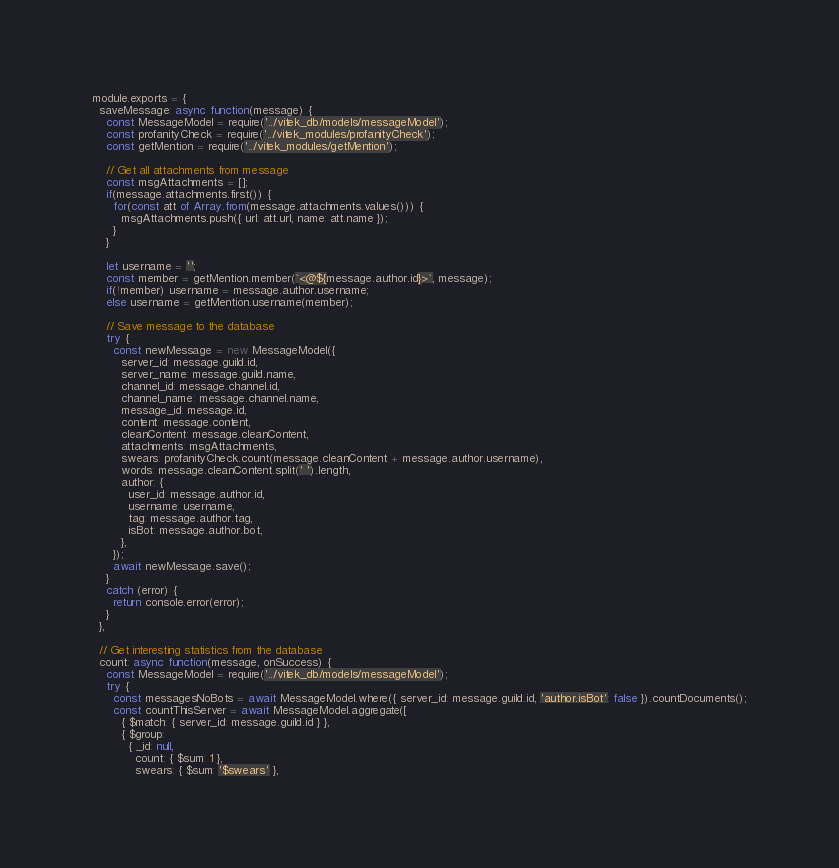<code> <loc_0><loc_0><loc_500><loc_500><_JavaScript_>module.exports = {
  saveMessage: async function(message) {
    const MessageModel = require('../vitek_db/models/messageModel');
    const profanityCheck = require('../vitek_modules/profanityCheck');
    const getMention = require('../vitek_modules/getMention');

    // Get all attachments from message
    const msgAttachments = [];
    if(message.attachments.first()) {
      for(const att of Array.from(message.attachments.values())) {
        msgAttachments.push({ url: att.url, name: att.name });
      }
    }

    let username = '';
    const member = getMention.member(`<@${message.author.id}>`, message);
    if(!member) username = message.author.username;
    else username = getMention.username(member);

    // Save message to the database
    try {
      const newMessage = new MessageModel({
        server_id: message.guild.id,
        server_name: message.guild.name,
        channel_id: message.channel.id,
        channel_name: message.channel.name,
        message_id: message.id,
        content: message.content,
        cleanContent: message.cleanContent,
        attachments: msgAttachments,
        swears: profanityCheck.count(message.cleanContent + message.author.username),
        words: message.cleanContent.split(' ').length,
        author: {
          user_id: message.author.id,
          username: username,
          tag: message.author.tag,
          isBot: message.author.bot,
        },
      });
      await newMessage.save();
    }
    catch (error) {
      return console.error(error);
    }
  },

  // Get interesting statistics from the database
  count: async function(message, onSuccess) {
    const MessageModel = require('../vitek_db/models/messageModel');
    try {
      const messagesNoBots = await MessageModel.where({ server_id: message.guild.id, 'author.isBot': false }).countDocuments();
      const countThisServer = await MessageModel.aggregate([
        { $match: { server_id: message.guild.id } },
        { $group:
          { _id: null,
            count: { $sum: 1 },
            swears: { $sum: '$swears' },</code> 